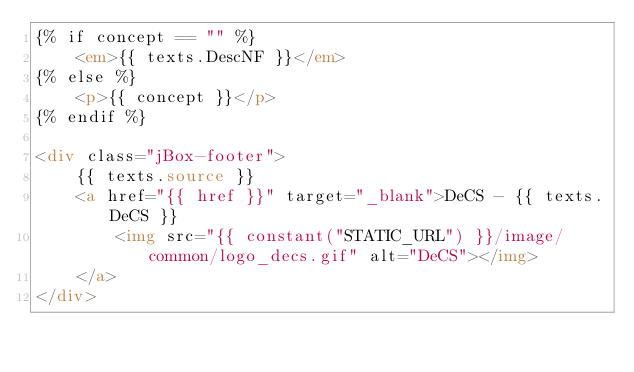<code> <loc_0><loc_0><loc_500><loc_500><_HTML_>{% if concept == "" %}
    <em>{{ texts.DescNF }}</em>
{% else %}
    <p>{{ concept }}</p>
{% endif %}

<div class="jBox-footer">
    {{ texts.source }}
    <a href="{{ href }}" target="_blank">DeCS - {{ texts.DeCS }}
        <img src="{{ constant("STATIC_URL") }}/image/common/logo_decs.gif" alt="DeCS"></img>
    </a>
</div>
</code> 